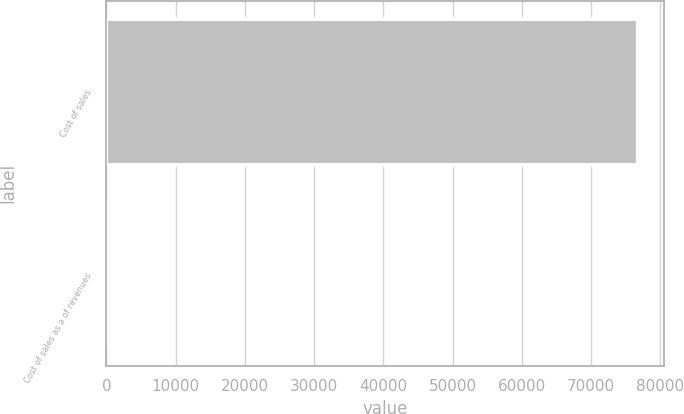Convert chart. <chart><loc_0><loc_0><loc_500><loc_500><bar_chart><fcel>Cost of sales<fcel>Cost of sales as a of revenues<nl><fcel>76752<fcel>84.6<nl></chart> 